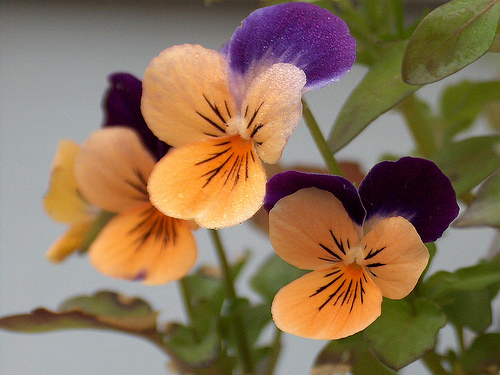<image>
Is the green leaf on the yellow flower? No. The green leaf is not positioned on the yellow flower. They may be near each other, but the green leaf is not supported by or resting on top of the yellow flower. Is the petal on the flower? No. The petal is not positioned on the flower. They may be near each other, but the petal is not supported by or resting on top of the flower. 